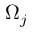<formula> <loc_0><loc_0><loc_500><loc_500>\Omega _ { j }</formula> 